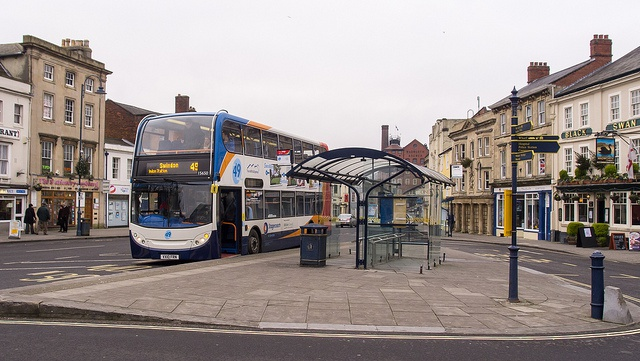Describe the objects in this image and their specific colors. I can see bus in white, black, gray, darkgray, and lightgray tones, bench in white, gray, black, and darkgray tones, people in white, black, gray, and maroon tones, people in white, black, gray, darkgray, and maroon tones, and car in white, gray, black, lightgray, and darkgray tones in this image. 